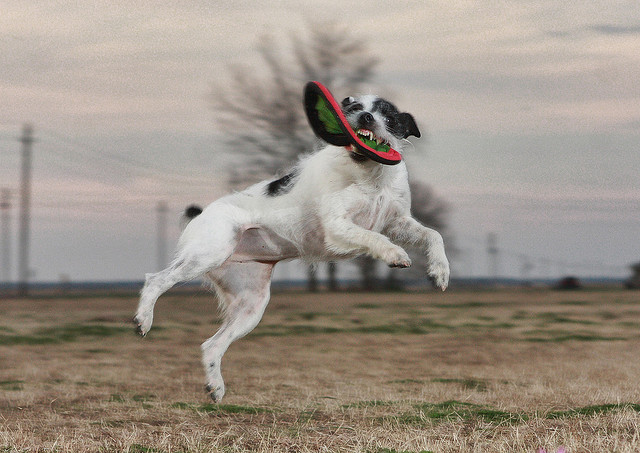What breed of dog is catching the frisbee? The dog appears to be a Border Collie, recognizable by its distinctive black and white coat and agile build, which is often associated with the breed's high intelligence and herding instincts. 